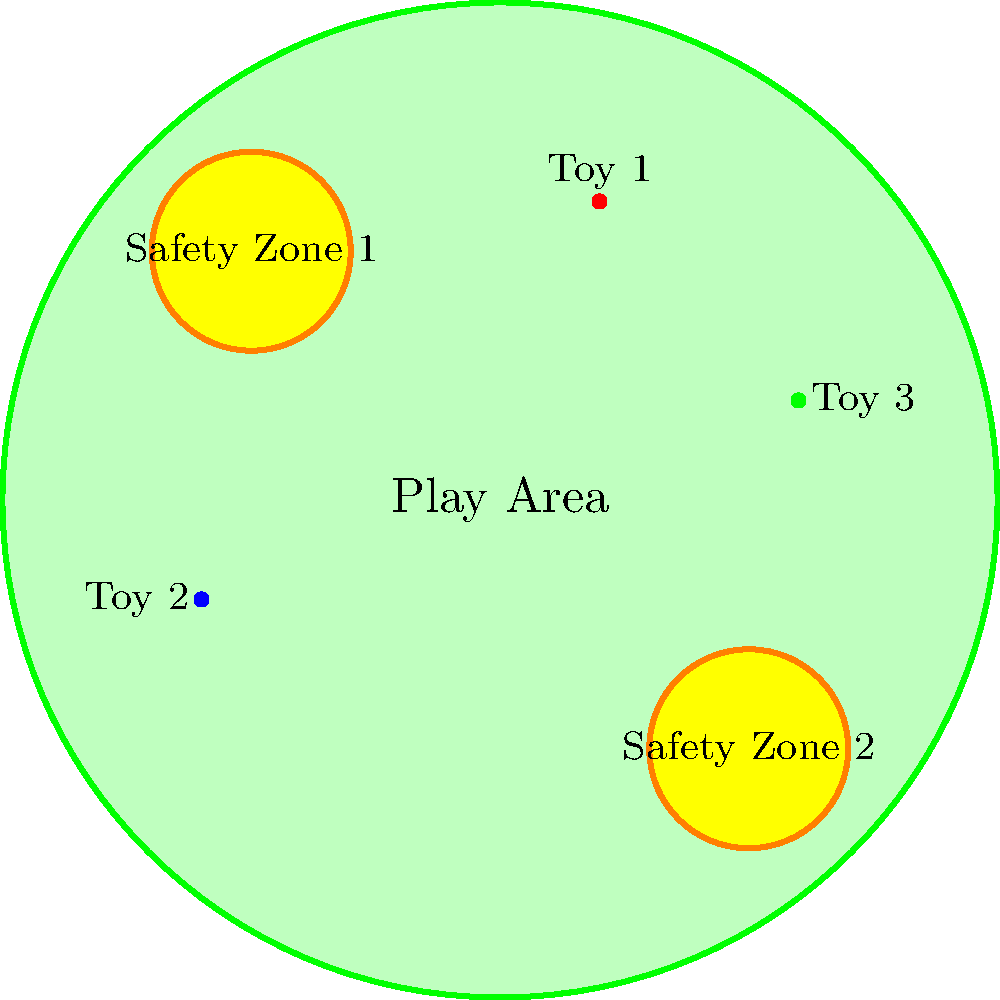In the given puppy play area layout, what is the optimal distance between the two safety zones to ensure maximum play space while maintaining quick access to safety for the puppies? Express your answer in terms of the play area radius $r$. To determine the optimal distance between the two safety zones, we need to follow these steps:

1. Identify the play area dimensions:
   The play area is a circle with radius $r$.

2. Locate the safety zones:
   The two safety zones are positioned diagonally across from each other.

3. Calculate the distance between safety zones:
   The centers of the safety zones form a diagonal across the play area.
   This diagonal is the diameter of the play area circle.

4. Express the diameter in terms of radius:
   Diameter = $2r$

5. Consider the size of safety zones:
   Each safety zone has a smaller radius, but this doesn't affect the center-to-center distance.

6. Optimal distance reasoning:
   The optimal distance should maximize play space while ensuring quick access to safety.
   Placing the safety zones at opposite ends of the diameter achieves this balance.

7. Conclusion:
   The optimal distance between the two safety zones is equal to the diameter of the play area, which is $2r$.

This arrangement allows puppies to have maximum play space in the center while always being within a reasonable distance from a safety zone.
Answer: $2r$ 